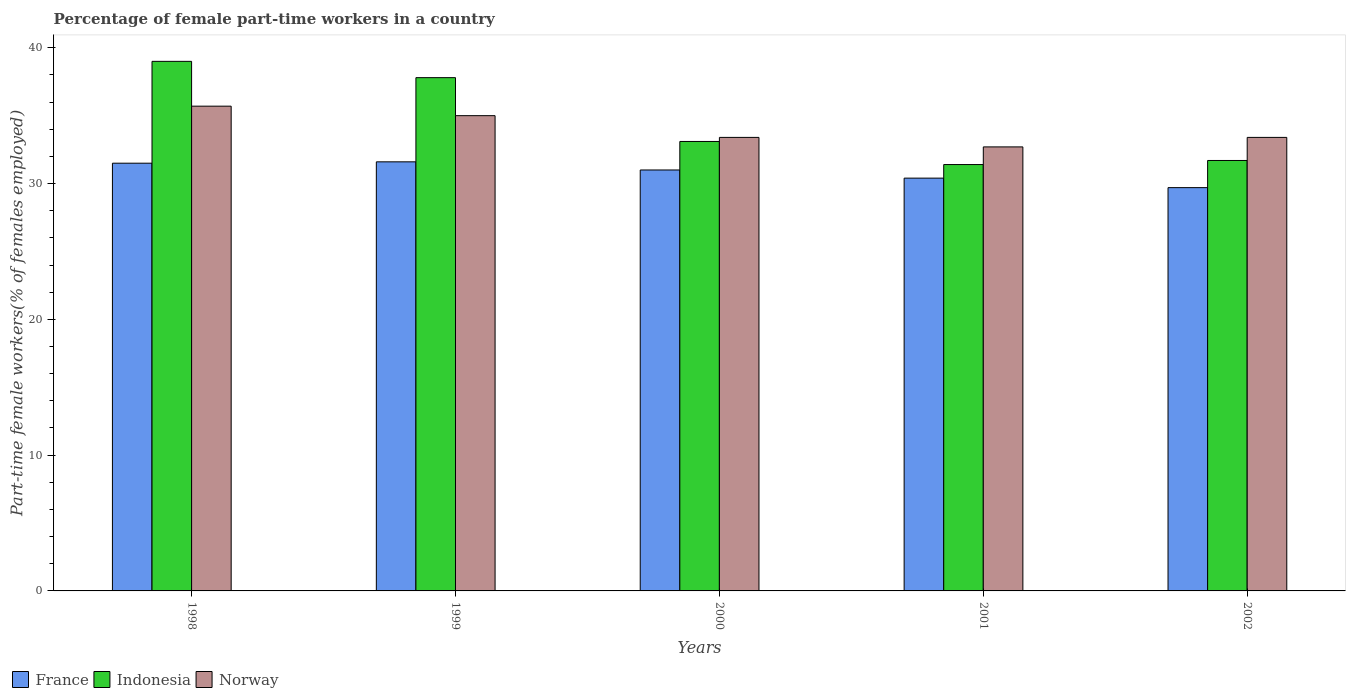Are the number of bars on each tick of the X-axis equal?
Give a very brief answer. Yes. How many bars are there on the 5th tick from the left?
Provide a succinct answer. 3. What is the label of the 1st group of bars from the left?
Your answer should be compact. 1998. In how many cases, is the number of bars for a given year not equal to the number of legend labels?
Make the answer very short. 0. What is the percentage of female part-time workers in Indonesia in 1999?
Provide a short and direct response. 37.8. Across all years, what is the maximum percentage of female part-time workers in France?
Your answer should be compact. 31.6. Across all years, what is the minimum percentage of female part-time workers in Norway?
Offer a very short reply. 32.7. In which year was the percentage of female part-time workers in Norway maximum?
Your answer should be compact. 1998. In which year was the percentage of female part-time workers in Indonesia minimum?
Keep it short and to the point. 2001. What is the total percentage of female part-time workers in Norway in the graph?
Give a very brief answer. 170.2. What is the difference between the percentage of female part-time workers in France in 1999 and that in 2002?
Your answer should be very brief. 1.9. What is the difference between the percentage of female part-time workers in France in 1998 and the percentage of female part-time workers in Norway in 2001?
Give a very brief answer. -1.2. What is the average percentage of female part-time workers in Norway per year?
Your answer should be very brief. 34.04. In the year 2002, what is the difference between the percentage of female part-time workers in Indonesia and percentage of female part-time workers in Norway?
Your answer should be compact. -1.7. In how many years, is the percentage of female part-time workers in France greater than 20 %?
Your answer should be very brief. 5. What is the ratio of the percentage of female part-time workers in Norway in 1998 to that in 2002?
Offer a very short reply. 1.07. Is the percentage of female part-time workers in Norway in 1999 less than that in 2001?
Provide a short and direct response. No. Is the difference between the percentage of female part-time workers in Indonesia in 2001 and 2002 greater than the difference between the percentage of female part-time workers in Norway in 2001 and 2002?
Your response must be concise. Yes. What is the difference between the highest and the second highest percentage of female part-time workers in France?
Make the answer very short. 0.1. What is the difference between the highest and the lowest percentage of female part-time workers in Indonesia?
Give a very brief answer. 7.6. Are all the bars in the graph horizontal?
Keep it short and to the point. No. How many years are there in the graph?
Your response must be concise. 5. Are the values on the major ticks of Y-axis written in scientific E-notation?
Keep it short and to the point. No. Where does the legend appear in the graph?
Offer a terse response. Bottom left. How many legend labels are there?
Make the answer very short. 3. How are the legend labels stacked?
Provide a succinct answer. Horizontal. What is the title of the graph?
Give a very brief answer. Percentage of female part-time workers in a country. What is the label or title of the Y-axis?
Your answer should be compact. Part-time female workers(% of females employed). What is the Part-time female workers(% of females employed) of France in 1998?
Your response must be concise. 31.5. What is the Part-time female workers(% of females employed) in Indonesia in 1998?
Provide a succinct answer. 39. What is the Part-time female workers(% of females employed) of Norway in 1998?
Your answer should be compact. 35.7. What is the Part-time female workers(% of females employed) in France in 1999?
Your answer should be compact. 31.6. What is the Part-time female workers(% of females employed) in Indonesia in 1999?
Give a very brief answer. 37.8. What is the Part-time female workers(% of females employed) of Indonesia in 2000?
Provide a succinct answer. 33.1. What is the Part-time female workers(% of females employed) in Norway in 2000?
Offer a terse response. 33.4. What is the Part-time female workers(% of females employed) of France in 2001?
Ensure brevity in your answer.  30.4. What is the Part-time female workers(% of females employed) in Indonesia in 2001?
Offer a terse response. 31.4. What is the Part-time female workers(% of females employed) in Norway in 2001?
Make the answer very short. 32.7. What is the Part-time female workers(% of females employed) in France in 2002?
Your response must be concise. 29.7. What is the Part-time female workers(% of females employed) in Indonesia in 2002?
Give a very brief answer. 31.7. What is the Part-time female workers(% of females employed) of Norway in 2002?
Give a very brief answer. 33.4. Across all years, what is the maximum Part-time female workers(% of females employed) in France?
Provide a succinct answer. 31.6. Across all years, what is the maximum Part-time female workers(% of females employed) of Norway?
Your answer should be compact. 35.7. Across all years, what is the minimum Part-time female workers(% of females employed) of France?
Provide a short and direct response. 29.7. Across all years, what is the minimum Part-time female workers(% of females employed) of Indonesia?
Your answer should be compact. 31.4. Across all years, what is the minimum Part-time female workers(% of females employed) in Norway?
Keep it short and to the point. 32.7. What is the total Part-time female workers(% of females employed) in France in the graph?
Keep it short and to the point. 154.2. What is the total Part-time female workers(% of females employed) in Indonesia in the graph?
Ensure brevity in your answer.  173. What is the total Part-time female workers(% of females employed) of Norway in the graph?
Keep it short and to the point. 170.2. What is the difference between the Part-time female workers(% of females employed) in France in 1998 and that in 1999?
Offer a very short reply. -0.1. What is the difference between the Part-time female workers(% of females employed) in Indonesia in 1998 and that in 1999?
Provide a succinct answer. 1.2. What is the difference between the Part-time female workers(% of females employed) in Norway in 1998 and that in 1999?
Ensure brevity in your answer.  0.7. What is the difference between the Part-time female workers(% of females employed) in Indonesia in 1998 and that in 2000?
Ensure brevity in your answer.  5.9. What is the difference between the Part-time female workers(% of females employed) of Norway in 1998 and that in 2000?
Your response must be concise. 2.3. What is the difference between the Part-time female workers(% of females employed) in Indonesia in 1998 and that in 2001?
Your response must be concise. 7.6. What is the difference between the Part-time female workers(% of females employed) of Norway in 1998 and that in 2001?
Ensure brevity in your answer.  3. What is the difference between the Part-time female workers(% of females employed) of Indonesia in 1999 and that in 2000?
Provide a succinct answer. 4.7. What is the difference between the Part-time female workers(% of females employed) in France in 1999 and that in 2001?
Keep it short and to the point. 1.2. What is the difference between the Part-time female workers(% of females employed) in France in 1999 and that in 2002?
Provide a succinct answer. 1.9. What is the difference between the Part-time female workers(% of females employed) in Indonesia in 1999 and that in 2002?
Your answer should be very brief. 6.1. What is the difference between the Part-time female workers(% of females employed) in France in 2000 and that in 2001?
Your answer should be compact. 0.6. What is the difference between the Part-time female workers(% of females employed) in Indonesia in 2000 and that in 2001?
Ensure brevity in your answer.  1.7. What is the difference between the Part-time female workers(% of females employed) of Norway in 2000 and that in 2001?
Offer a very short reply. 0.7. What is the difference between the Part-time female workers(% of females employed) of Norway in 2001 and that in 2002?
Your answer should be compact. -0.7. What is the difference between the Part-time female workers(% of females employed) in France in 1998 and the Part-time female workers(% of females employed) in Norway in 1999?
Provide a short and direct response. -3.5. What is the difference between the Part-time female workers(% of females employed) in Indonesia in 1998 and the Part-time female workers(% of females employed) in Norway in 1999?
Ensure brevity in your answer.  4. What is the difference between the Part-time female workers(% of females employed) in France in 1998 and the Part-time female workers(% of females employed) in Indonesia in 2000?
Offer a very short reply. -1.6. What is the difference between the Part-time female workers(% of females employed) in France in 1998 and the Part-time female workers(% of females employed) in Indonesia in 2001?
Offer a terse response. 0.1. What is the difference between the Part-time female workers(% of females employed) of France in 1998 and the Part-time female workers(% of females employed) of Norway in 2001?
Your answer should be very brief. -1.2. What is the difference between the Part-time female workers(% of females employed) of France in 1998 and the Part-time female workers(% of females employed) of Norway in 2002?
Offer a terse response. -1.9. What is the difference between the Part-time female workers(% of females employed) in Indonesia in 1998 and the Part-time female workers(% of females employed) in Norway in 2002?
Your answer should be very brief. 5.6. What is the difference between the Part-time female workers(% of females employed) of France in 1999 and the Part-time female workers(% of females employed) of Indonesia in 2000?
Offer a terse response. -1.5. What is the difference between the Part-time female workers(% of females employed) in France in 1999 and the Part-time female workers(% of females employed) in Indonesia in 2001?
Your answer should be very brief. 0.2. What is the difference between the Part-time female workers(% of females employed) of France in 1999 and the Part-time female workers(% of females employed) of Norway in 2001?
Keep it short and to the point. -1.1. What is the difference between the Part-time female workers(% of females employed) of France in 1999 and the Part-time female workers(% of females employed) of Indonesia in 2002?
Your answer should be compact. -0.1. What is the difference between the Part-time female workers(% of females employed) of France in 1999 and the Part-time female workers(% of females employed) of Norway in 2002?
Provide a short and direct response. -1.8. What is the difference between the Part-time female workers(% of females employed) in Indonesia in 1999 and the Part-time female workers(% of females employed) in Norway in 2002?
Give a very brief answer. 4.4. What is the difference between the Part-time female workers(% of females employed) of France in 2000 and the Part-time female workers(% of females employed) of Norway in 2001?
Provide a succinct answer. -1.7. What is the difference between the Part-time female workers(% of females employed) of Indonesia in 2000 and the Part-time female workers(% of females employed) of Norway in 2001?
Offer a terse response. 0.4. What is the difference between the Part-time female workers(% of females employed) in France in 2000 and the Part-time female workers(% of females employed) in Indonesia in 2002?
Make the answer very short. -0.7. What is the difference between the Part-time female workers(% of females employed) in France in 2000 and the Part-time female workers(% of females employed) in Norway in 2002?
Your answer should be very brief. -2.4. What is the difference between the Part-time female workers(% of females employed) of Indonesia in 2000 and the Part-time female workers(% of females employed) of Norway in 2002?
Keep it short and to the point. -0.3. What is the difference between the Part-time female workers(% of females employed) of France in 2001 and the Part-time female workers(% of females employed) of Indonesia in 2002?
Offer a terse response. -1.3. What is the average Part-time female workers(% of females employed) of France per year?
Keep it short and to the point. 30.84. What is the average Part-time female workers(% of females employed) in Indonesia per year?
Your answer should be compact. 34.6. What is the average Part-time female workers(% of females employed) of Norway per year?
Provide a short and direct response. 34.04. In the year 1998, what is the difference between the Part-time female workers(% of females employed) in France and Part-time female workers(% of females employed) in Indonesia?
Your answer should be compact. -7.5. In the year 1998, what is the difference between the Part-time female workers(% of females employed) in France and Part-time female workers(% of females employed) in Norway?
Your answer should be compact. -4.2. In the year 1998, what is the difference between the Part-time female workers(% of females employed) of Indonesia and Part-time female workers(% of females employed) of Norway?
Your answer should be very brief. 3.3. In the year 1999, what is the difference between the Part-time female workers(% of females employed) in France and Part-time female workers(% of females employed) in Norway?
Make the answer very short. -3.4. In the year 1999, what is the difference between the Part-time female workers(% of females employed) in Indonesia and Part-time female workers(% of females employed) in Norway?
Offer a terse response. 2.8. In the year 2000, what is the difference between the Part-time female workers(% of females employed) in France and Part-time female workers(% of females employed) in Indonesia?
Your answer should be compact. -2.1. In the year 2000, what is the difference between the Part-time female workers(% of females employed) of France and Part-time female workers(% of females employed) of Norway?
Your response must be concise. -2.4. In the year 2001, what is the difference between the Part-time female workers(% of females employed) of France and Part-time female workers(% of females employed) of Norway?
Your response must be concise. -2.3. In the year 2001, what is the difference between the Part-time female workers(% of females employed) in Indonesia and Part-time female workers(% of females employed) in Norway?
Your response must be concise. -1.3. In the year 2002, what is the difference between the Part-time female workers(% of females employed) of France and Part-time female workers(% of females employed) of Indonesia?
Keep it short and to the point. -2. What is the ratio of the Part-time female workers(% of females employed) of Indonesia in 1998 to that in 1999?
Make the answer very short. 1.03. What is the ratio of the Part-time female workers(% of females employed) in Norway in 1998 to that in 1999?
Your answer should be compact. 1.02. What is the ratio of the Part-time female workers(% of females employed) of France in 1998 to that in 2000?
Provide a succinct answer. 1.02. What is the ratio of the Part-time female workers(% of females employed) of Indonesia in 1998 to that in 2000?
Your response must be concise. 1.18. What is the ratio of the Part-time female workers(% of females employed) in Norway in 1998 to that in 2000?
Ensure brevity in your answer.  1.07. What is the ratio of the Part-time female workers(% of females employed) of France in 1998 to that in 2001?
Your answer should be very brief. 1.04. What is the ratio of the Part-time female workers(% of females employed) of Indonesia in 1998 to that in 2001?
Provide a short and direct response. 1.24. What is the ratio of the Part-time female workers(% of females employed) of Norway in 1998 to that in 2001?
Provide a short and direct response. 1.09. What is the ratio of the Part-time female workers(% of females employed) of France in 1998 to that in 2002?
Your answer should be compact. 1.06. What is the ratio of the Part-time female workers(% of females employed) of Indonesia in 1998 to that in 2002?
Your response must be concise. 1.23. What is the ratio of the Part-time female workers(% of females employed) in Norway in 1998 to that in 2002?
Provide a succinct answer. 1.07. What is the ratio of the Part-time female workers(% of females employed) of France in 1999 to that in 2000?
Ensure brevity in your answer.  1.02. What is the ratio of the Part-time female workers(% of females employed) of Indonesia in 1999 to that in 2000?
Provide a short and direct response. 1.14. What is the ratio of the Part-time female workers(% of females employed) of Norway in 1999 to that in 2000?
Your answer should be compact. 1.05. What is the ratio of the Part-time female workers(% of females employed) in France in 1999 to that in 2001?
Ensure brevity in your answer.  1.04. What is the ratio of the Part-time female workers(% of females employed) in Indonesia in 1999 to that in 2001?
Provide a succinct answer. 1.2. What is the ratio of the Part-time female workers(% of females employed) in Norway in 1999 to that in 2001?
Give a very brief answer. 1.07. What is the ratio of the Part-time female workers(% of females employed) in France in 1999 to that in 2002?
Your answer should be very brief. 1.06. What is the ratio of the Part-time female workers(% of females employed) in Indonesia in 1999 to that in 2002?
Your response must be concise. 1.19. What is the ratio of the Part-time female workers(% of females employed) of Norway in 1999 to that in 2002?
Give a very brief answer. 1.05. What is the ratio of the Part-time female workers(% of females employed) of France in 2000 to that in 2001?
Offer a terse response. 1.02. What is the ratio of the Part-time female workers(% of females employed) of Indonesia in 2000 to that in 2001?
Your response must be concise. 1.05. What is the ratio of the Part-time female workers(% of females employed) in Norway in 2000 to that in 2001?
Give a very brief answer. 1.02. What is the ratio of the Part-time female workers(% of females employed) in France in 2000 to that in 2002?
Your response must be concise. 1.04. What is the ratio of the Part-time female workers(% of females employed) in Indonesia in 2000 to that in 2002?
Your answer should be compact. 1.04. What is the ratio of the Part-time female workers(% of females employed) of France in 2001 to that in 2002?
Ensure brevity in your answer.  1.02. What is the difference between the highest and the second highest Part-time female workers(% of females employed) in France?
Provide a succinct answer. 0.1. What is the difference between the highest and the second highest Part-time female workers(% of females employed) of Indonesia?
Keep it short and to the point. 1.2. What is the difference between the highest and the lowest Part-time female workers(% of females employed) in France?
Give a very brief answer. 1.9. What is the difference between the highest and the lowest Part-time female workers(% of females employed) in Indonesia?
Ensure brevity in your answer.  7.6. 